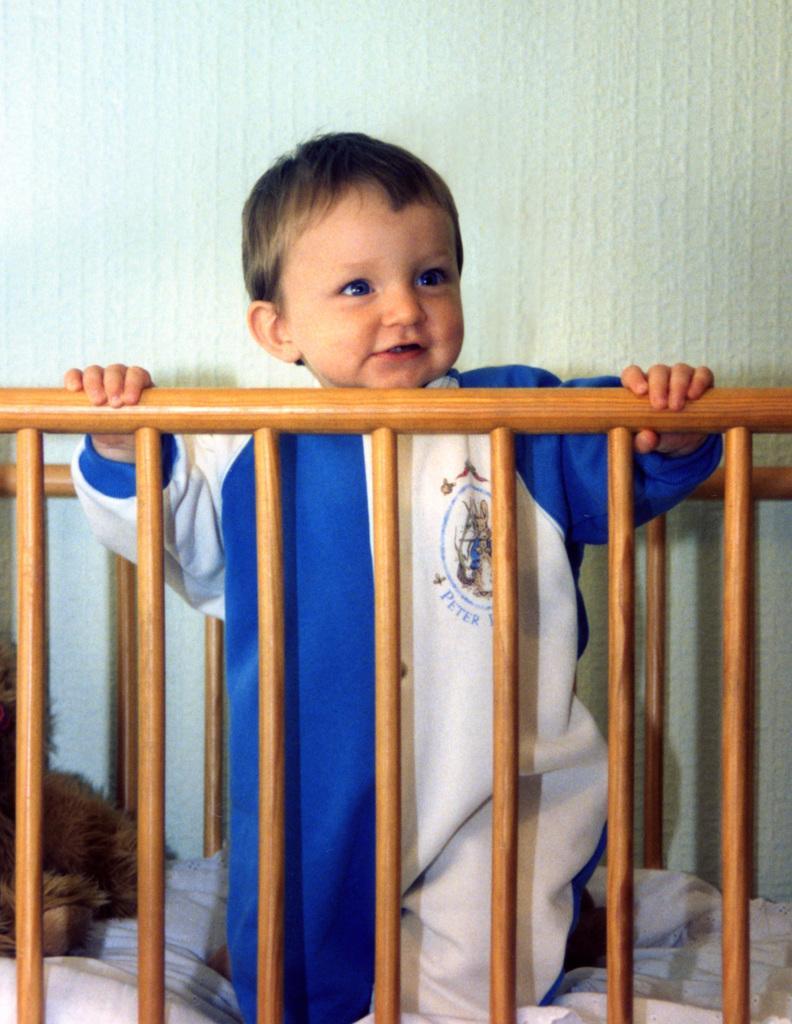Could you give a brief overview of what you see in this image? In this image we can see a boy and a toy on the bed, in the background we can see the wall. 